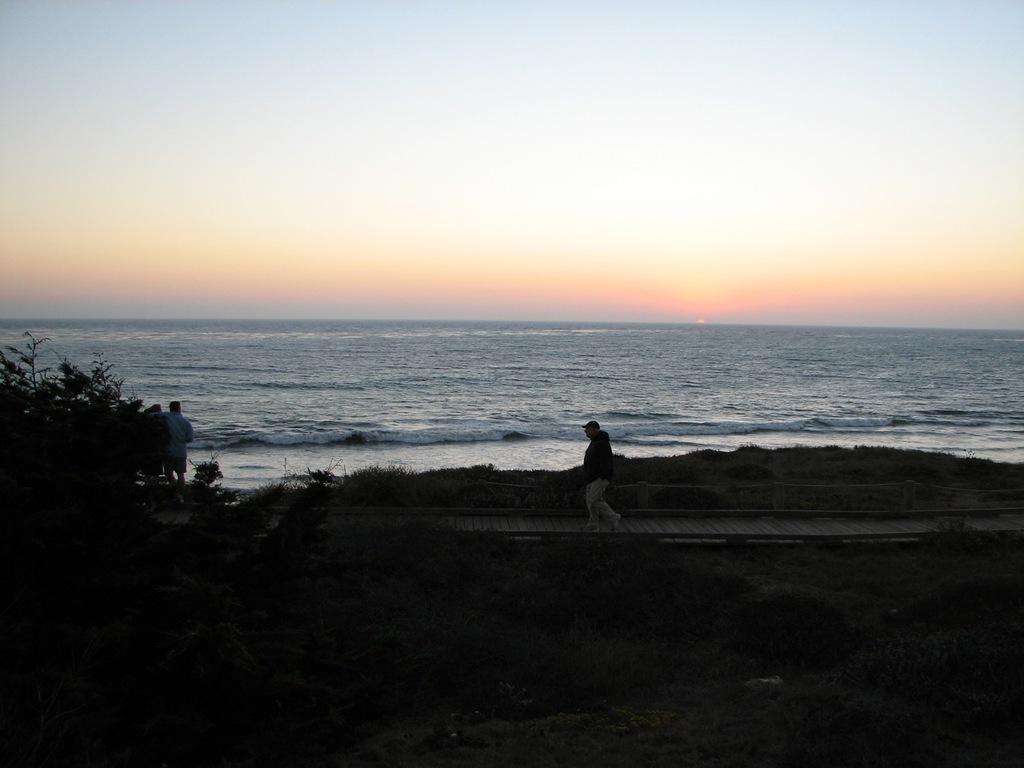What is located in the center of the image? There are plants in the center of the image. What are the people in the image doing? The persons in the image are standing and walking. What can be seen in the background of the image? There is water visible in the background of the image. What type of seed is being planted in the office in the image? There is no office or seed planting present in the image; it features plants in the center and people standing and walking. 